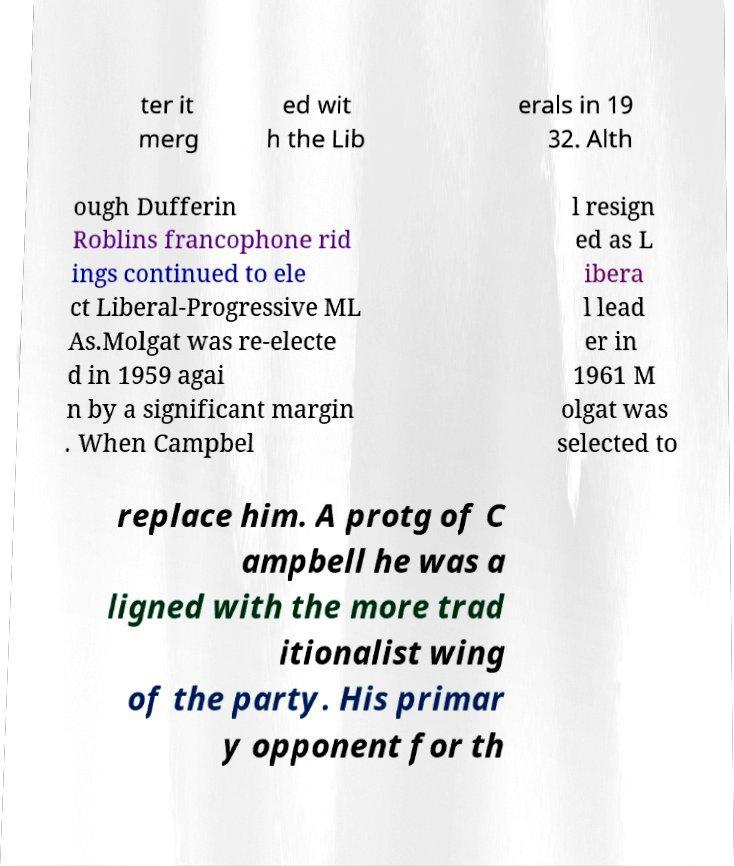What messages or text are displayed in this image? I need them in a readable, typed format. ter it merg ed wit h the Lib erals in 19 32. Alth ough Dufferin Roblins francophone rid ings continued to ele ct Liberal-Progressive ML As.Molgat was re-electe d in 1959 agai n by a significant margin . When Campbel l resign ed as L ibera l lead er in 1961 M olgat was selected to replace him. A protg of C ampbell he was a ligned with the more trad itionalist wing of the party. His primar y opponent for th 